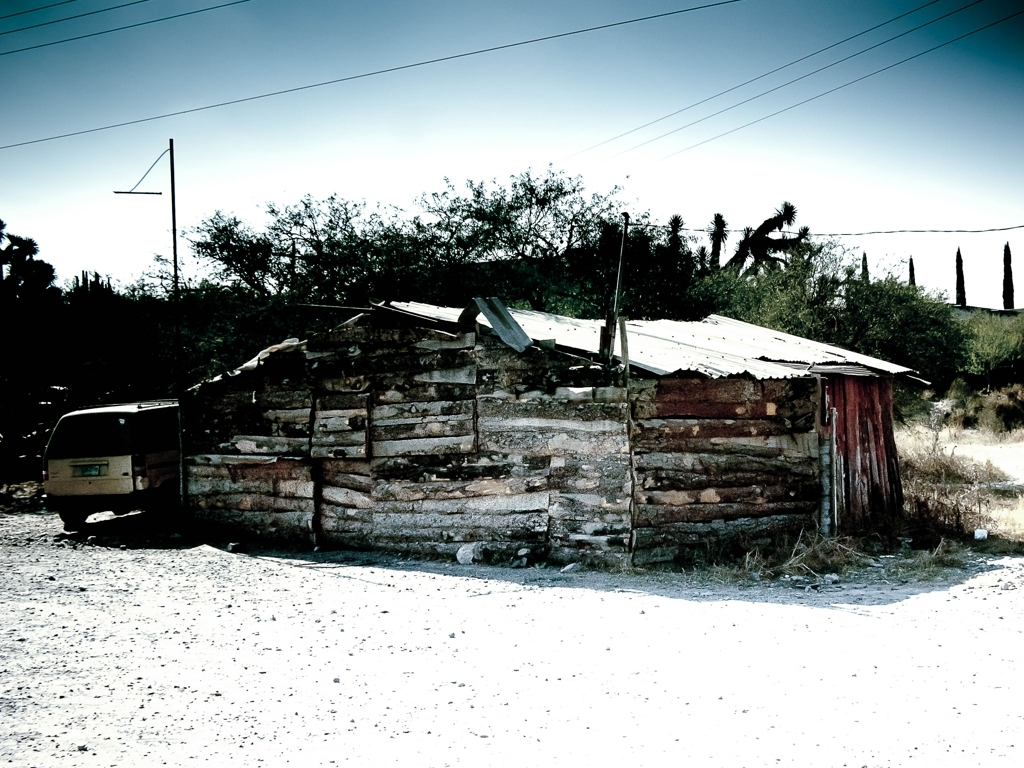Can you infer what climate or region this might be? The vegetation, such as the cacti and shrubbery, as well as the construction style of the building, suggest a dry or arid climate, possibly a region similar to parts of the Southwestern United States or Mexico. 